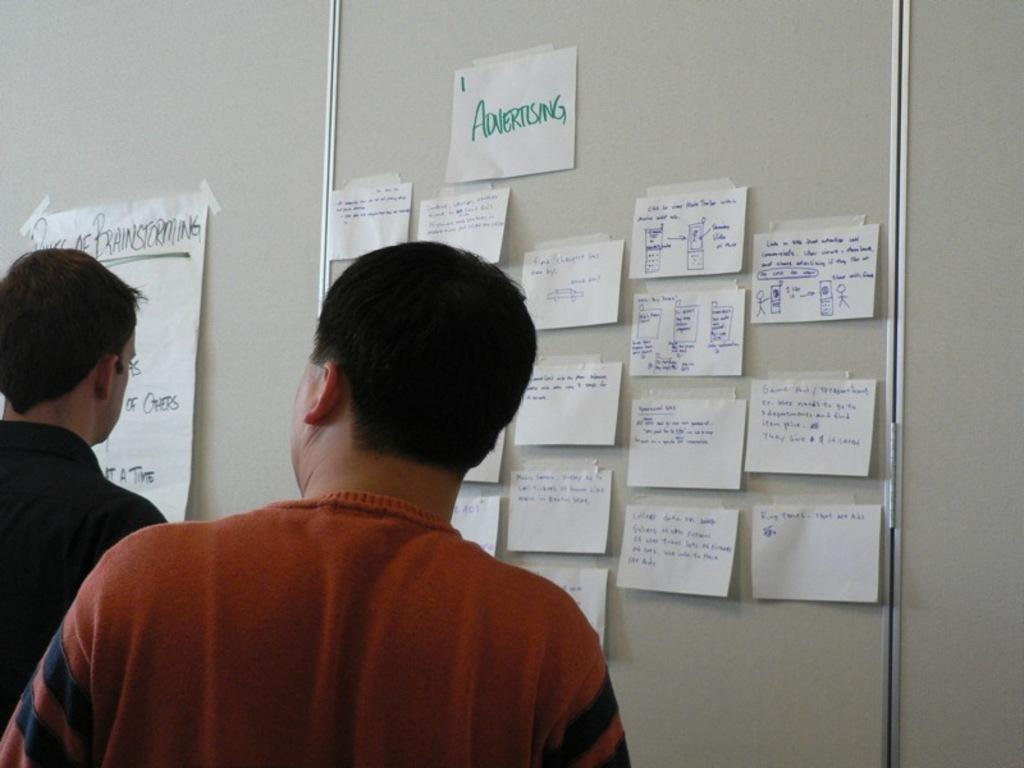How many people are in the image? There are two men in the image. What can be seen on the wall in front of the men? There are papers on the wall in front of the men. What type of house is visible in the image? There is no house visible in the image; it only features two men and papers on the wall. 